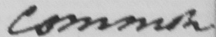Please provide the text content of this handwritten line. common 